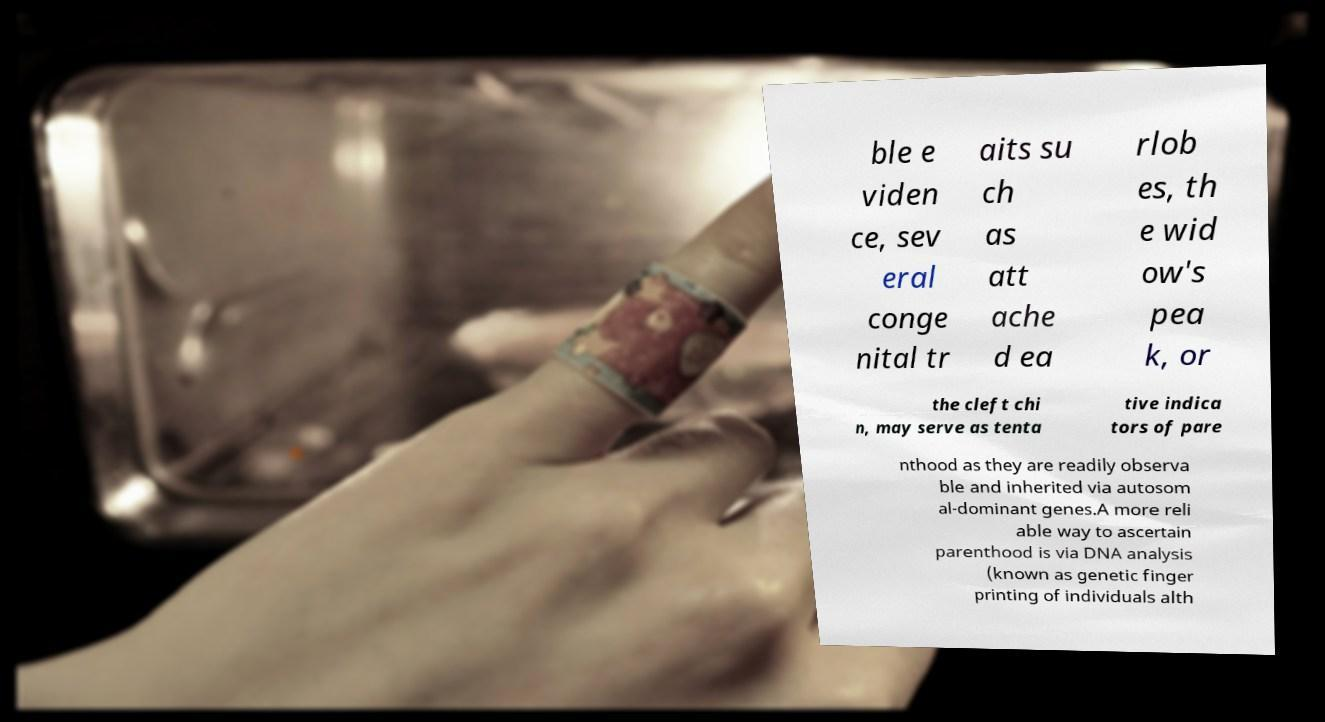I need the written content from this picture converted into text. Can you do that? ble e viden ce, sev eral conge nital tr aits su ch as att ache d ea rlob es, th e wid ow's pea k, or the cleft chi n, may serve as tenta tive indica tors of pare nthood as they are readily observa ble and inherited via autosom al-dominant genes.A more reli able way to ascertain parenthood is via DNA analysis (known as genetic finger printing of individuals alth 